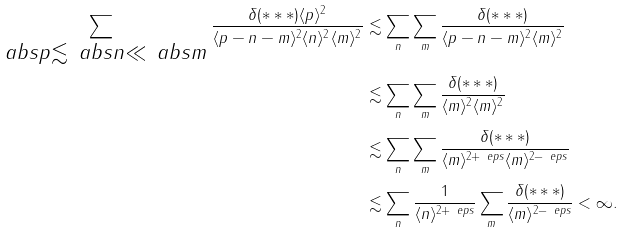<formula> <loc_0><loc_0><loc_500><loc_500>\sum _ { \substack { \ a b s { p } \lesssim \ a b s { n } \ll \ a b s { m } } } \frac { \delta ( * * * ) \langle p \rangle ^ { 2 } } { \langle { p - n - m } \rangle ^ { 2 } \langle n \rangle ^ { 2 } \langle m \rangle ^ { 2 } } & \lesssim \sum _ { n } \sum _ { m } \frac { \delta ( * * * ) } { \langle { p - n - m } \rangle ^ { 2 } \langle m \rangle ^ { 2 } } \\ & \lesssim \sum _ { n } \sum _ { m } \frac { \delta ( * * * ) } { \langle m \rangle ^ { 2 } \langle m \rangle ^ { 2 } } \\ & \lesssim \sum _ { n } \sum _ { m } \frac { \delta ( * * * ) } { \langle m \rangle ^ { 2 + \ e p s } \langle m \rangle ^ { 2 - \ e p s } } \\ & \lesssim \sum _ { n } \frac { 1 } { \langle n \rangle ^ { 2 + \ e p s } } \sum _ { m } \frac { \delta ( * * * ) } { \langle m \rangle ^ { 2 - \ e p s } } < \infty .</formula> 